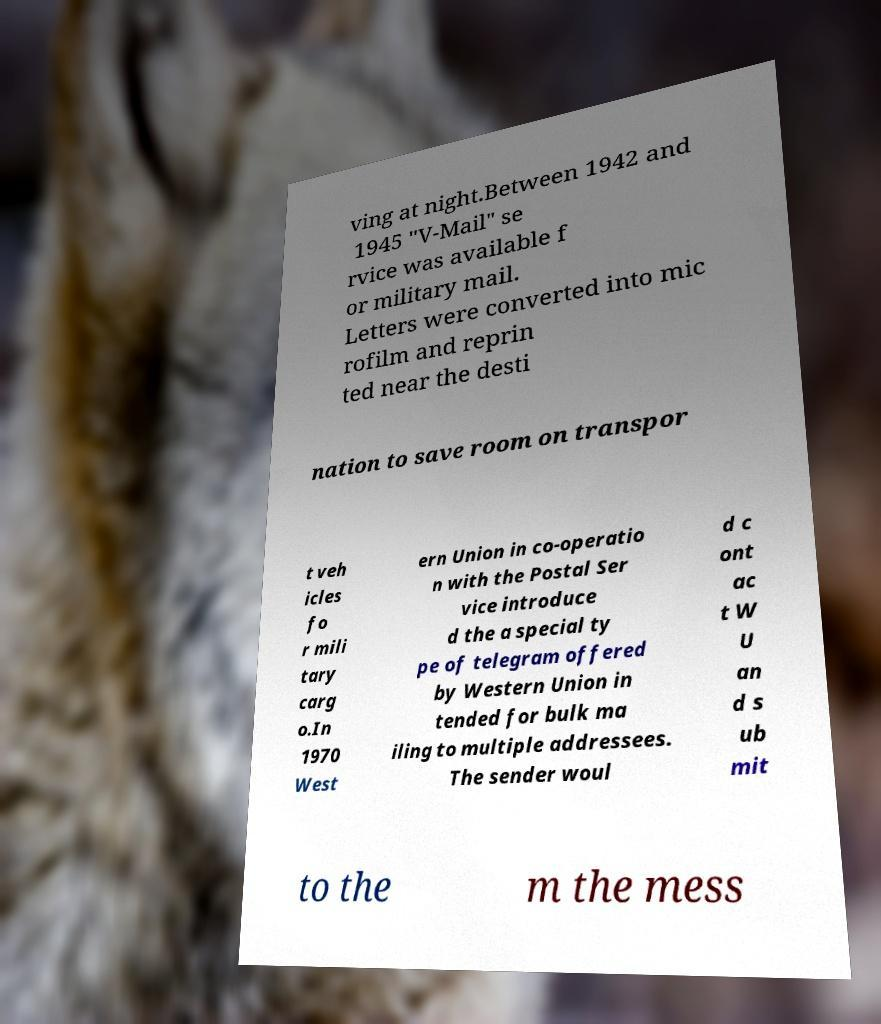Could you assist in decoding the text presented in this image and type it out clearly? ving at night.Between 1942 and 1945 "V-Mail" se rvice was available f or military mail. Letters were converted into mic rofilm and reprin ted near the desti nation to save room on transpor t veh icles fo r mili tary carg o.In 1970 West ern Union in co-operatio n with the Postal Ser vice introduce d the a special ty pe of telegram offered by Western Union in tended for bulk ma iling to multiple addressees. The sender woul d c ont ac t W U an d s ub mit to the m the mess 